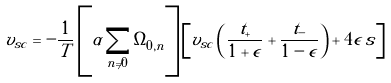Convert formula to latex. <formula><loc_0><loc_0><loc_500><loc_500>v _ { s c } = - \frac { 1 } { T } \left [ \alpha \sum _ { n \ne 0 } \Omega _ { 0 , n } \right ] \left [ v _ { s c } \left ( \frac { t _ { + } } { 1 + \epsilon } + \frac { t _ { - } } { 1 - \epsilon } \right ) + 4 \epsilon \, s \right ]</formula> 